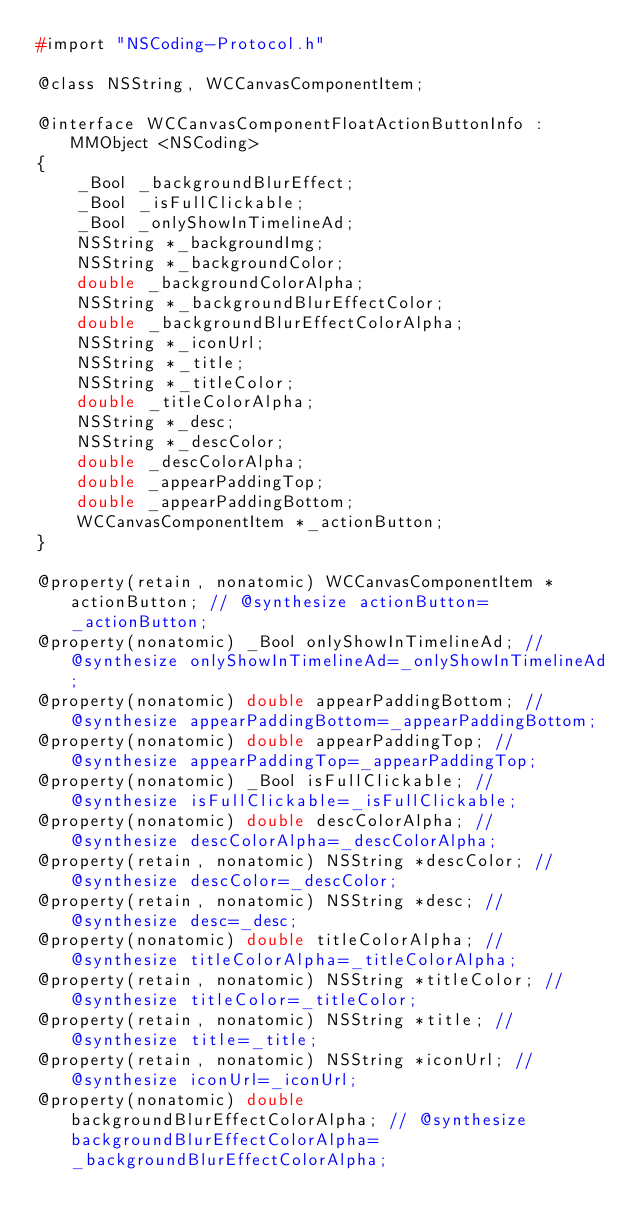Convert code to text. <code><loc_0><loc_0><loc_500><loc_500><_C_>#import "NSCoding-Protocol.h"

@class NSString, WCCanvasComponentItem;

@interface WCCanvasComponentFloatActionButtonInfo : MMObject <NSCoding>
{
    _Bool _backgroundBlurEffect;
    _Bool _isFullClickable;
    _Bool _onlyShowInTimelineAd;
    NSString *_backgroundImg;
    NSString *_backgroundColor;
    double _backgroundColorAlpha;
    NSString *_backgroundBlurEffectColor;
    double _backgroundBlurEffectColorAlpha;
    NSString *_iconUrl;
    NSString *_title;
    NSString *_titleColor;
    double _titleColorAlpha;
    NSString *_desc;
    NSString *_descColor;
    double _descColorAlpha;
    double _appearPaddingTop;
    double _appearPaddingBottom;
    WCCanvasComponentItem *_actionButton;
}

@property(retain, nonatomic) WCCanvasComponentItem *actionButton; // @synthesize actionButton=_actionButton;
@property(nonatomic) _Bool onlyShowInTimelineAd; // @synthesize onlyShowInTimelineAd=_onlyShowInTimelineAd;
@property(nonatomic) double appearPaddingBottom; // @synthesize appearPaddingBottom=_appearPaddingBottom;
@property(nonatomic) double appearPaddingTop; // @synthesize appearPaddingTop=_appearPaddingTop;
@property(nonatomic) _Bool isFullClickable; // @synthesize isFullClickable=_isFullClickable;
@property(nonatomic) double descColorAlpha; // @synthesize descColorAlpha=_descColorAlpha;
@property(retain, nonatomic) NSString *descColor; // @synthesize descColor=_descColor;
@property(retain, nonatomic) NSString *desc; // @synthesize desc=_desc;
@property(nonatomic) double titleColorAlpha; // @synthesize titleColorAlpha=_titleColorAlpha;
@property(retain, nonatomic) NSString *titleColor; // @synthesize titleColor=_titleColor;
@property(retain, nonatomic) NSString *title; // @synthesize title=_title;
@property(retain, nonatomic) NSString *iconUrl; // @synthesize iconUrl=_iconUrl;
@property(nonatomic) double backgroundBlurEffectColorAlpha; // @synthesize backgroundBlurEffectColorAlpha=_backgroundBlurEffectColorAlpha;</code> 